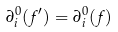Convert formula to latex. <formula><loc_0><loc_0><loc_500><loc_500>\partial ^ { 0 } _ { i } ( f ^ { \prime } ) = \partial ^ { 0 } _ { i } ( f )</formula> 